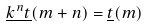Convert formula to latex. <formula><loc_0><loc_0><loc_500><loc_500>\underline { k ^ { n } t } ( m + n ) = \underline { t } ( m )</formula> 